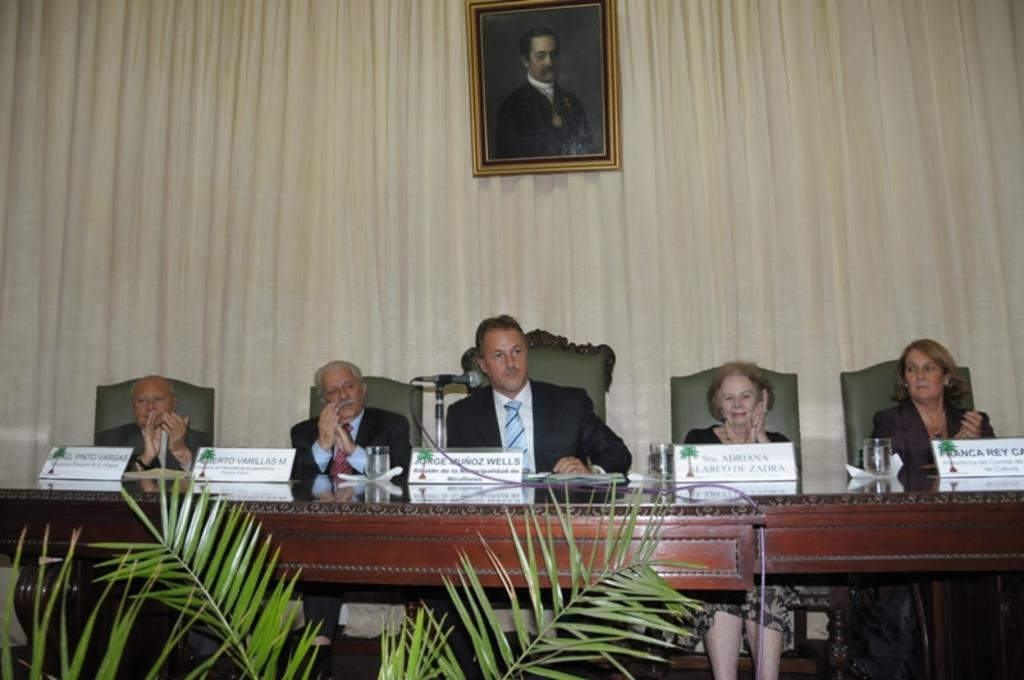How many people are sitting in the image? There are five persons sitting on chairs in the image. What is present on the table in the image? There are glasses on the table in the image. What object is used for amplifying sound in the image? There is a microphone (mike) in the image. What can be seen in the background of the image? There is a curtain in the background of the image. What type of object is present in the image that might be used for displaying photos or artwork? There is a frame in the image. What type of ear is visible in the image? There is no ear present in the image. How does the sense of smell play a role in the image? The sense of smell is not mentioned or depicted in the image. 